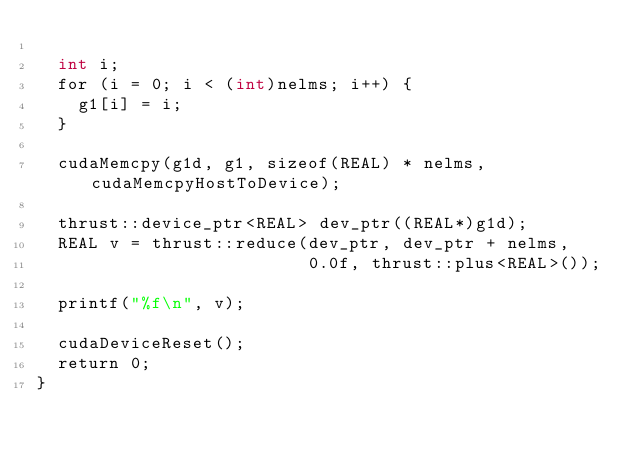<code> <loc_0><loc_0><loc_500><loc_500><_Cuda_>
  int i;
  for (i = 0; i < (int)nelms; i++) {
    g1[i] = i;
  }
    
  cudaMemcpy(g1d, g1, sizeof(REAL) * nelms, cudaMemcpyHostToDevice);
  
  thrust::device_ptr<REAL> dev_ptr((REAL*)g1d);
  REAL v = thrust::reduce(dev_ptr, dev_ptr + nelms,
                          0.0f, thrust::plus<REAL>());

  printf("%f\n", v);
  
  cudaDeviceReset();
  return 0;
}

</code> 